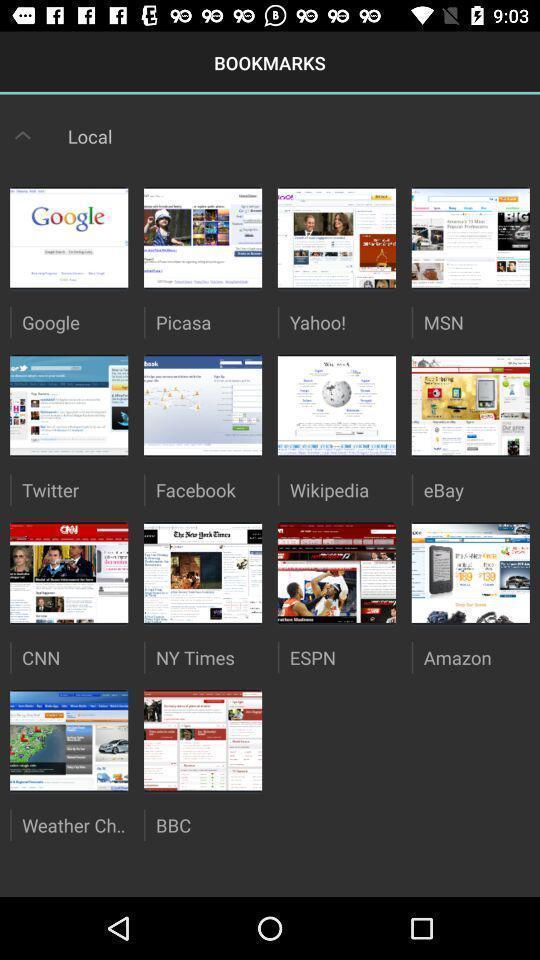What is the overall content of this screenshot? Screen shows list of bookmarks. 